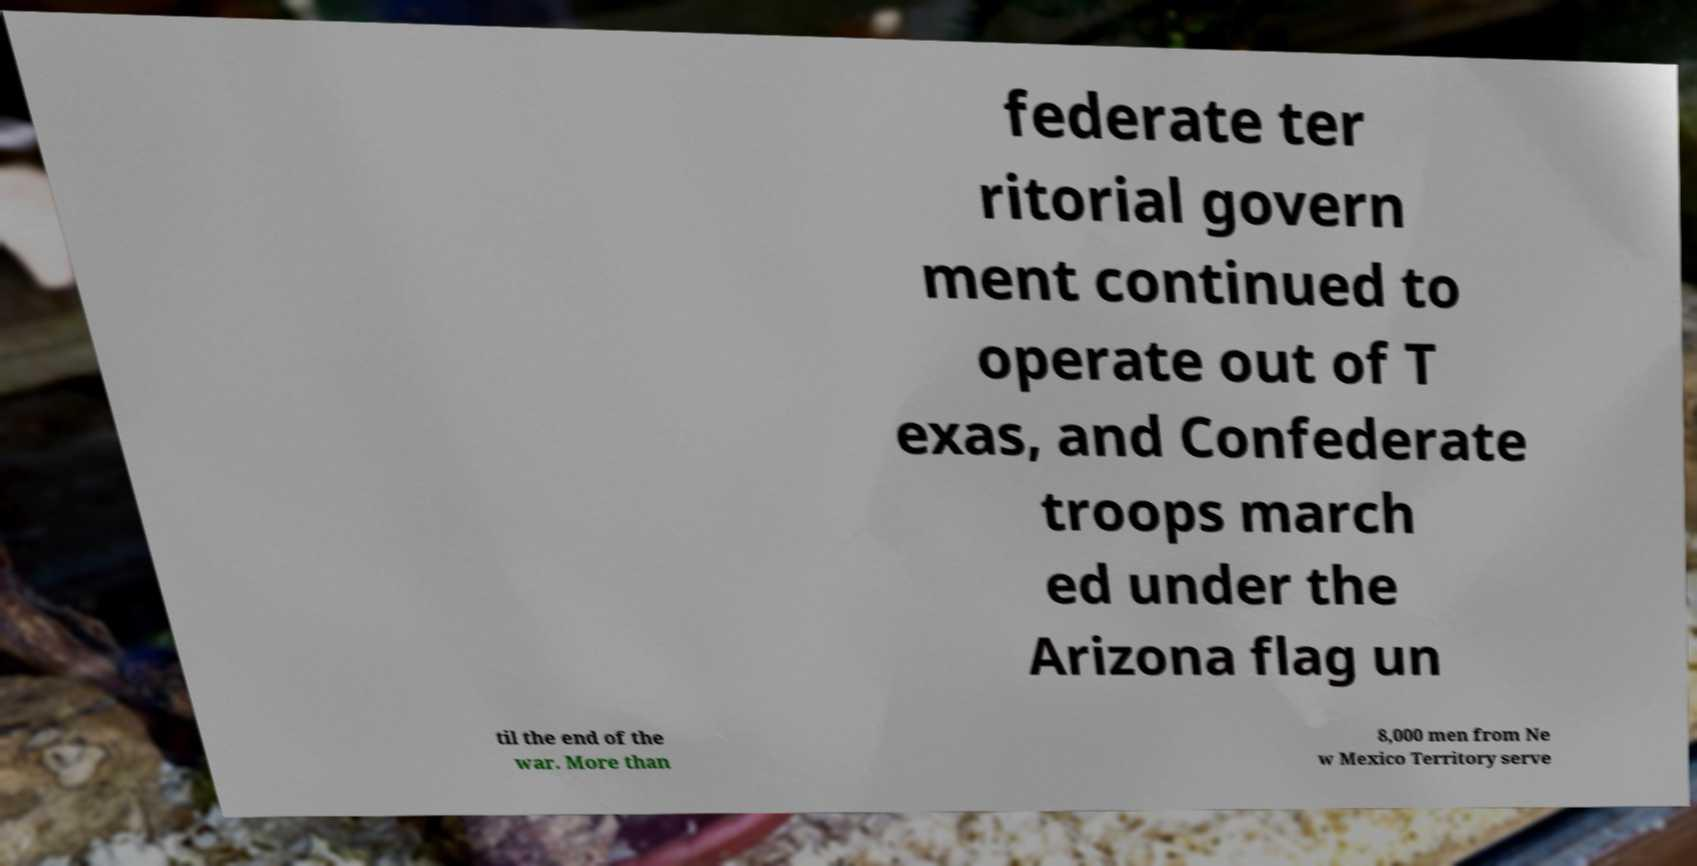Can you read and provide the text displayed in the image?This photo seems to have some interesting text. Can you extract and type it out for me? federate ter ritorial govern ment continued to operate out of T exas, and Confederate troops march ed under the Arizona flag un til the end of the war. More than 8,000 men from Ne w Mexico Territory serve 